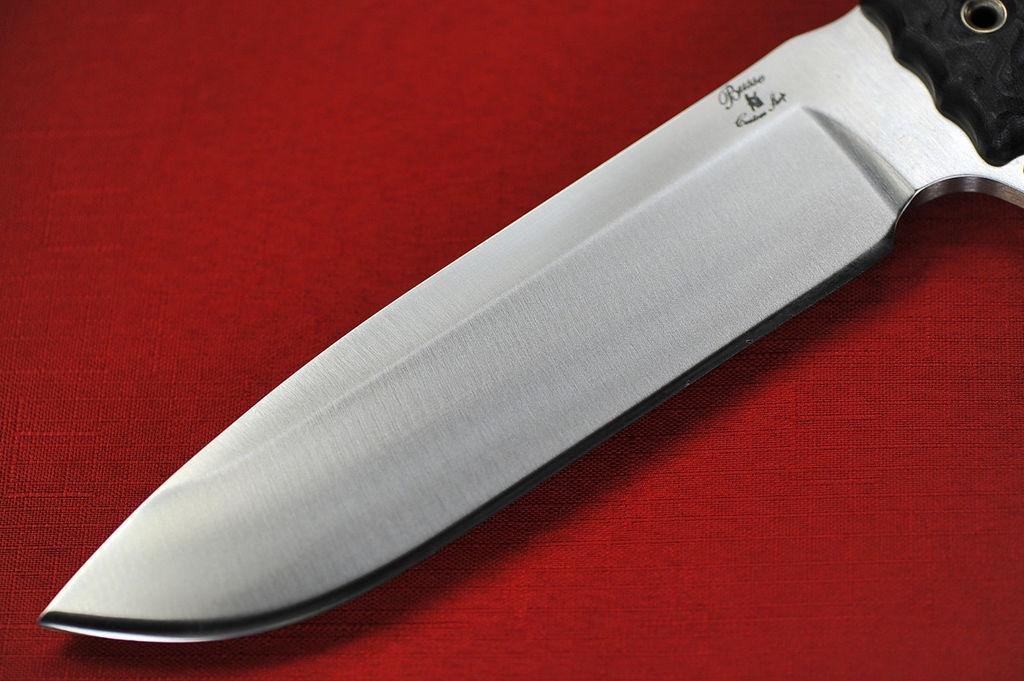What object is present in the image that can be used for cutting? There is a knife in the image that can be used for cutting. Is there any specific place for the knife in the image? Yes, there is a holder for the knife in the image. What can be observed on the knife itself? The knife has text and a symbol on it. What color is the surface on which the knife is placed? The knife is placed on a red surface. Can you tell me how many cabbages are in the image? There are no cabbages present in the image. What type of slope can be seen in the image? There is no slope present in the image. 